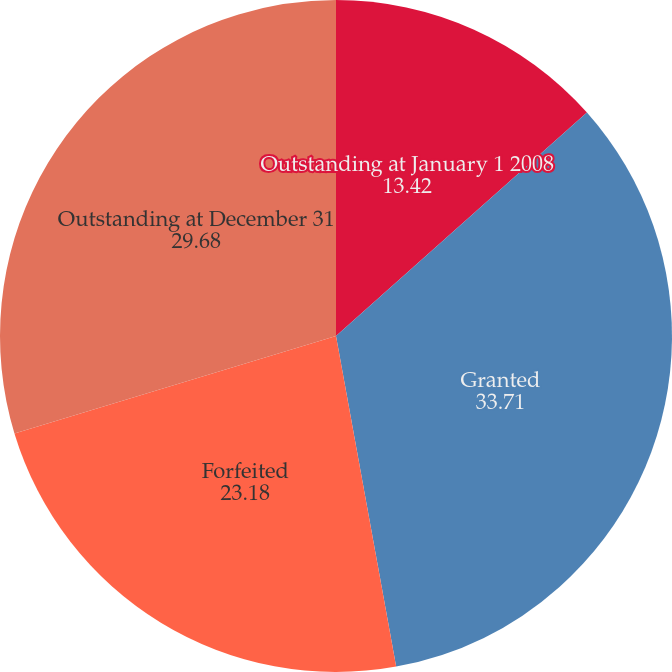Convert chart to OTSL. <chart><loc_0><loc_0><loc_500><loc_500><pie_chart><fcel>Outstanding at January 1 2008<fcel>Granted<fcel>Forfeited<fcel>Outstanding at December 31<nl><fcel>13.42%<fcel>33.71%<fcel>23.18%<fcel>29.68%<nl></chart> 